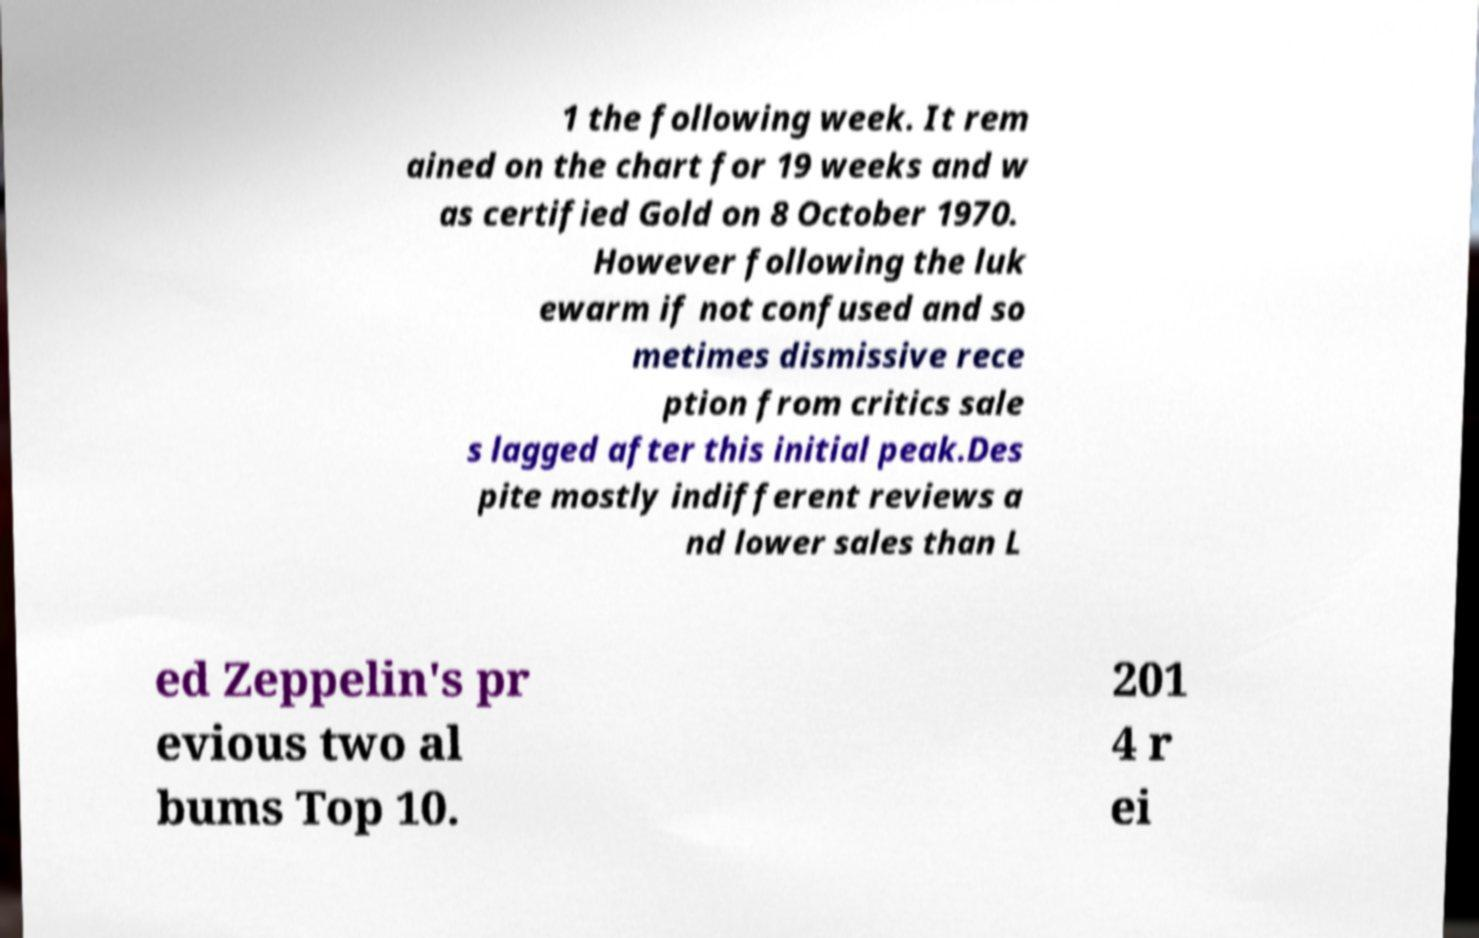Could you assist in decoding the text presented in this image and type it out clearly? 1 the following week. It rem ained on the chart for 19 weeks and w as certified Gold on 8 October 1970. However following the luk ewarm if not confused and so metimes dismissive rece ption from critics sale s lagged after this initial peak.Des pite mostly indifferent reviews a nd lower sales than L ed Zeppelin's pr evious two al bums Top 10. 201 4 r ei 